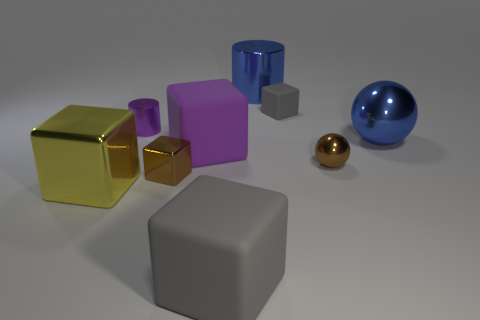Subtract all yellow blocks. How many blocks are left? 4 Subtract all blue blocks. Subtract all gray cylinders. How many blocks are left? 5 Subtract all cylinders. How many objects are left? 7 Subtract all large metallic cubes. Subtract all tiny shiny cylinders. How many objects are left? 7 Add 9 tiny metallic blocks. How many tiny metallic blocks are left? 10 Add 3 purple metallic things. How many purple metallic things exist? 4 Subtract 1 blue spheres. How many objects are left? 8 